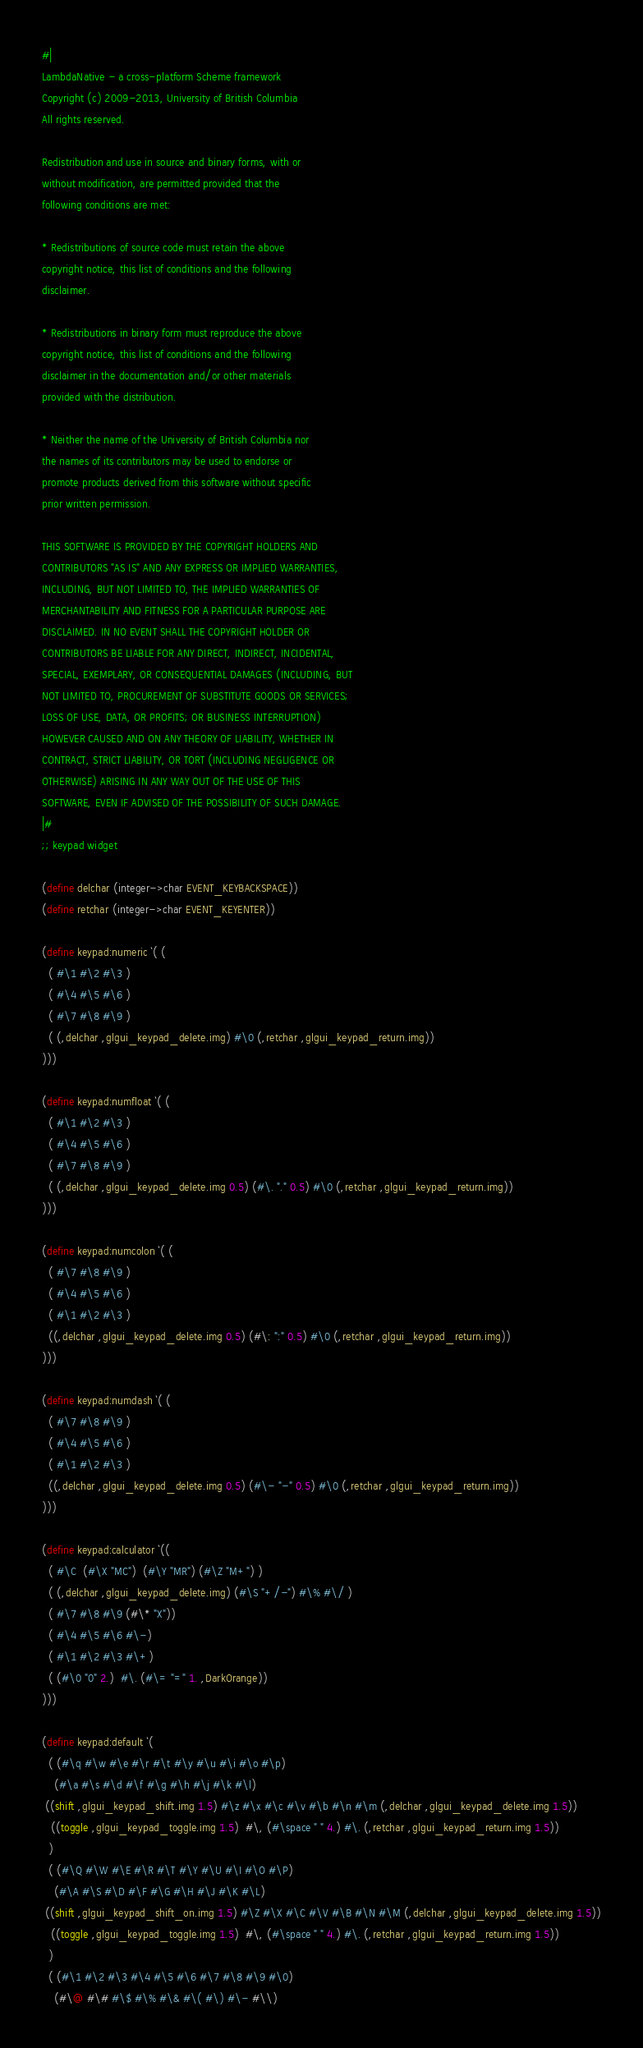<code> <loc_0><loc_0><loc_500><loc_500><_Scheme_>#|
LambdaNative - a cross-platform Scheme framework
Copyright (c) 2009-2013, University of British Columbia
All rights reserved.

Redistribution and use in source and binary forms, with or
without modification, are permitted provided that the
following conditions are met:

* Redistributions of source code must retain the above
copyright notice, this list of conditions and the following
disclaimer.

* Redistributions in binary form must reproduce the above
copyright notice, this list of conditions and the following
disclaimer in the documentation and/or other materials
provided with the distribution.

* Neither the name of the University of British Columbia nor
the names of its contributors may be used to endorse or
promote products derived from this software without specific
prior written permission.

THIS SOFTWARE IS PROVIDED BY THE COPYRIGHT HOLDERS AND
CONTRIBUTORS "AS IS" AND ANY EXPRESS OR IMPLIED WARRANTIES,
INCLUDING, BUT NOT LIMITED TO, THE IMPLIED WARRANTIES OF
MERCHANTABILITY AND FITNESS FOR A PARTICULAR PURPOSE ARE
DISCLAIMED. IN NO EVENT SHALL THE COPYRIGHT HOLDER OR
CONTRIBUTORS BE LIABLE FOR ANY DIRECT, INDIRECT, INCIDENTAL,
SPECIAL, EXEMPLARY, OR CONSEQUENTIAL DAMAGES (INCLUDING, BUT
NOT LIMITED TO, PROCUREMENT OF SUBSTITUTE GOODS OR SERVICES;
LOSS OF USE, DATA, OR PROFITS; OR BUSINESS INTERRUPTION)
HOWEVER CAUSED AND ON ANY THEORY OF LIABILITY, WHETHER IN
CONTRACT, STRICT LIABILITY, OR TORT (INCLUDING NEGLIGENCE OR
OTHERWISE) ARISING IN ANY WAY OUT OF THE USE OF THIS
SOFTWARE, EVEN IF ADVISED OF THE POSSIBILITY OF SUCH DAMAGE.
|#
;; keypad widget

(define delchar (integer->char EVENT_KEYBACKSPACE))
(define retchar (integer->char EVENT_KEYENTER))

(define keypad:numeric `( (
  ( #\1 #\2 #\3 )
  ( #\4 #\5 #\6 )
  ( #\7 #\8 #\9 )
  ( (,delchar ,glgui_keypad_delete.img) #\0 (,retchar ,glgui_keypad_return.img))
)))

(define keypad:numfloat `( (
  ( #\1 #\2 #\3 )
  ( #\4 #\5 #\6 )
  ( #\7 #\8 #\9 )
  ( (,delchar ,glgui_keypad_delete.img 0.5) (#\. "." 0.5) #\0 (,retchar ,glgui_keypad_return.img))
)))

(define keypad:numcolon `( (
  ( #\7 #\8 #\9 )
  ( #\4 #\5 #\6 )
  ( #\1 #\2 #\3 )
  ((,delchar ,glgui_keypad_delete.img 0.5) (#\: ":" 0.5) #\0 (,retchar ,glgui_keypad_return.img))
)))

(define keypad:numdash `( (
  ( #\7 #\8 #\9 )
  ( #\4 #\5 #\6 )
  ( #\1 #\2 #\3 )
  ((,delchar ,glgui_keypad_delete.img 0.5) (#\- "-" 0.5) #\0 (,retchar ,glgui_keypad_return.img))
)))

(define keypad:calculator `((
  ( #\C  (#\X "MC")  (#\Y "MR") (#\Z "M+") )
  ( (,delchar ,glgui_keypad_delete.img) (#\S "+/-") #\% #\/ )
  ( #\7 #\8 #\9 (#\* "X"))
  ( #\4 #\5 #\6 #\-)
  ( #\1 #\2 #\3 #\+)
  ( (#\0 "0" 2.)  #\. (#\= "=" 1. ,DarkOrange))
)))

(define keypad:default `(
  ( (#\q #\w #\e #\r #\t #\y #\u #\i #\o #\p)
    (#\a #\s #\d #\f #\g #\h #\j #\k #\l)
 ((shift ,glgui_keypad_shift.img 1.5) #\z #\x #\c #\v #\b #\n #\m (,delchar ,glgui_keypad_delete.img 1.5))
   ((toggle ,glgui_keypad_toggle.img 1.5)  #\, (#\space " " 4.) #\. (,retchar ,glgui_keypad_return.img 1.5))
  )
  ( (#\Q #\W #\E #\R #\T #\Y #\U #\I #\O #\P)
    (#\A #\S #\D #\F #\G #\H #\J #\K #\L)
 ((shift ,glgui_keypad_shift_on.img 1.5) #\Z #\X #\C #\V #\B #\N #\M (,delchar ,glgui_keypad_delete.img 1.5))
   ((toggle ,glgui_keypad_toggle.img 1.5)  #\, (#\space " " 4.) #\. (,retchar ,glgui_keypad_return.img 1.5))
  )
  ( (#\1 #\2 #\3 #\4 #\5 #\6 #\7 #\8 #\9 #\0)
    (#\@ #\# #\$ #\% #\& #\( #\) #\- #\\)</code> 